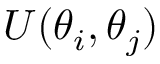<formula> <loc_0><loc_0><loc_500><loc_500>U ( \theta _ { i } , \theta _ { j } )</formula> 